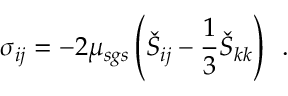Convert formula to latex. <formula><loc_0><loc_0><loc_500><loc_500>\sigma _ { i j } = - 2 \mu _ { s g s } \left ( \check { S } _ { i j } - \frac { 1 } { 3 } \check { S } _ { k k } \right ) \, .</formula> 